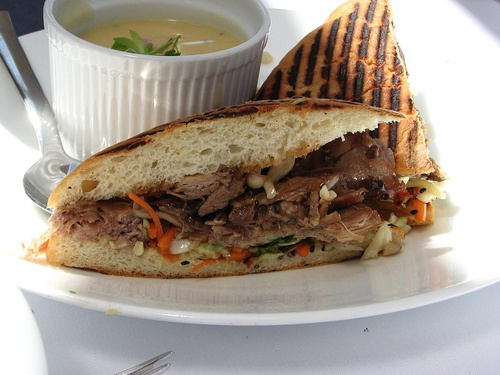Describe the objects in this image and their specific colors. I can see dining table in white, darkgray, tan, maroon, and black tones, sandwich in black, maroon, and tan tones, bowl in black, lightgray, darkgray, and gray tones, sandwich in black, maroon, and tan tones, and spoon in black, lightgray, darkgray, and gray tones in this image. 